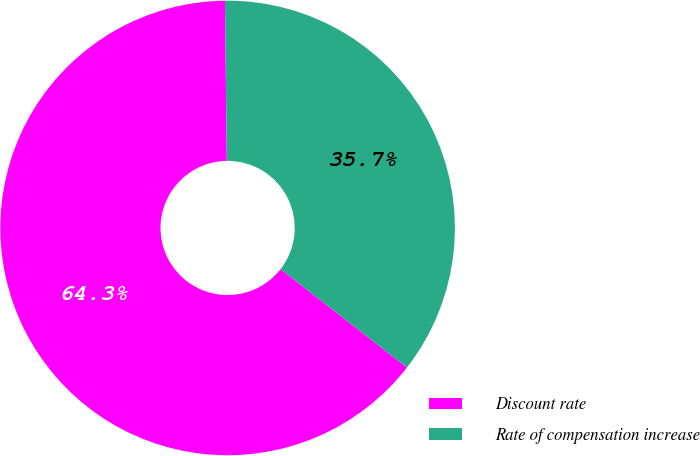Convert chart. <chart><loc_0><loc_0><loc_500><loc_500><pie_chart><fcel>Discount rate<fcel>Rate of compensation increase<nl><fcel>64.29%<fcel>35.71%<nl></chart> 